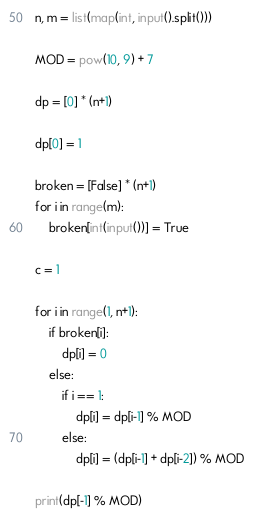Convert code to text. <code><loc_0><loc_0><loc_500><loc_500><_Python_>n, m = list(map(int, input().split()))

MOD = pow(10, 9) + 7

dp = [0] * (n+1)

dp[0] = 1

broken = [False] * (n+1)
for i in range(m):
    broken[int(input())] = True

c = 1

for i in range(1, n+1):
    if broken[i]:
        dp[i] = 0
    else:
        if i == 1:
            dp[i] = dp[i-1] % MOD
        else:
            dp[i] = (dp[i-1] + dp[i-2]) % MOD

print(dp[-1] % MOD) 
</code> 